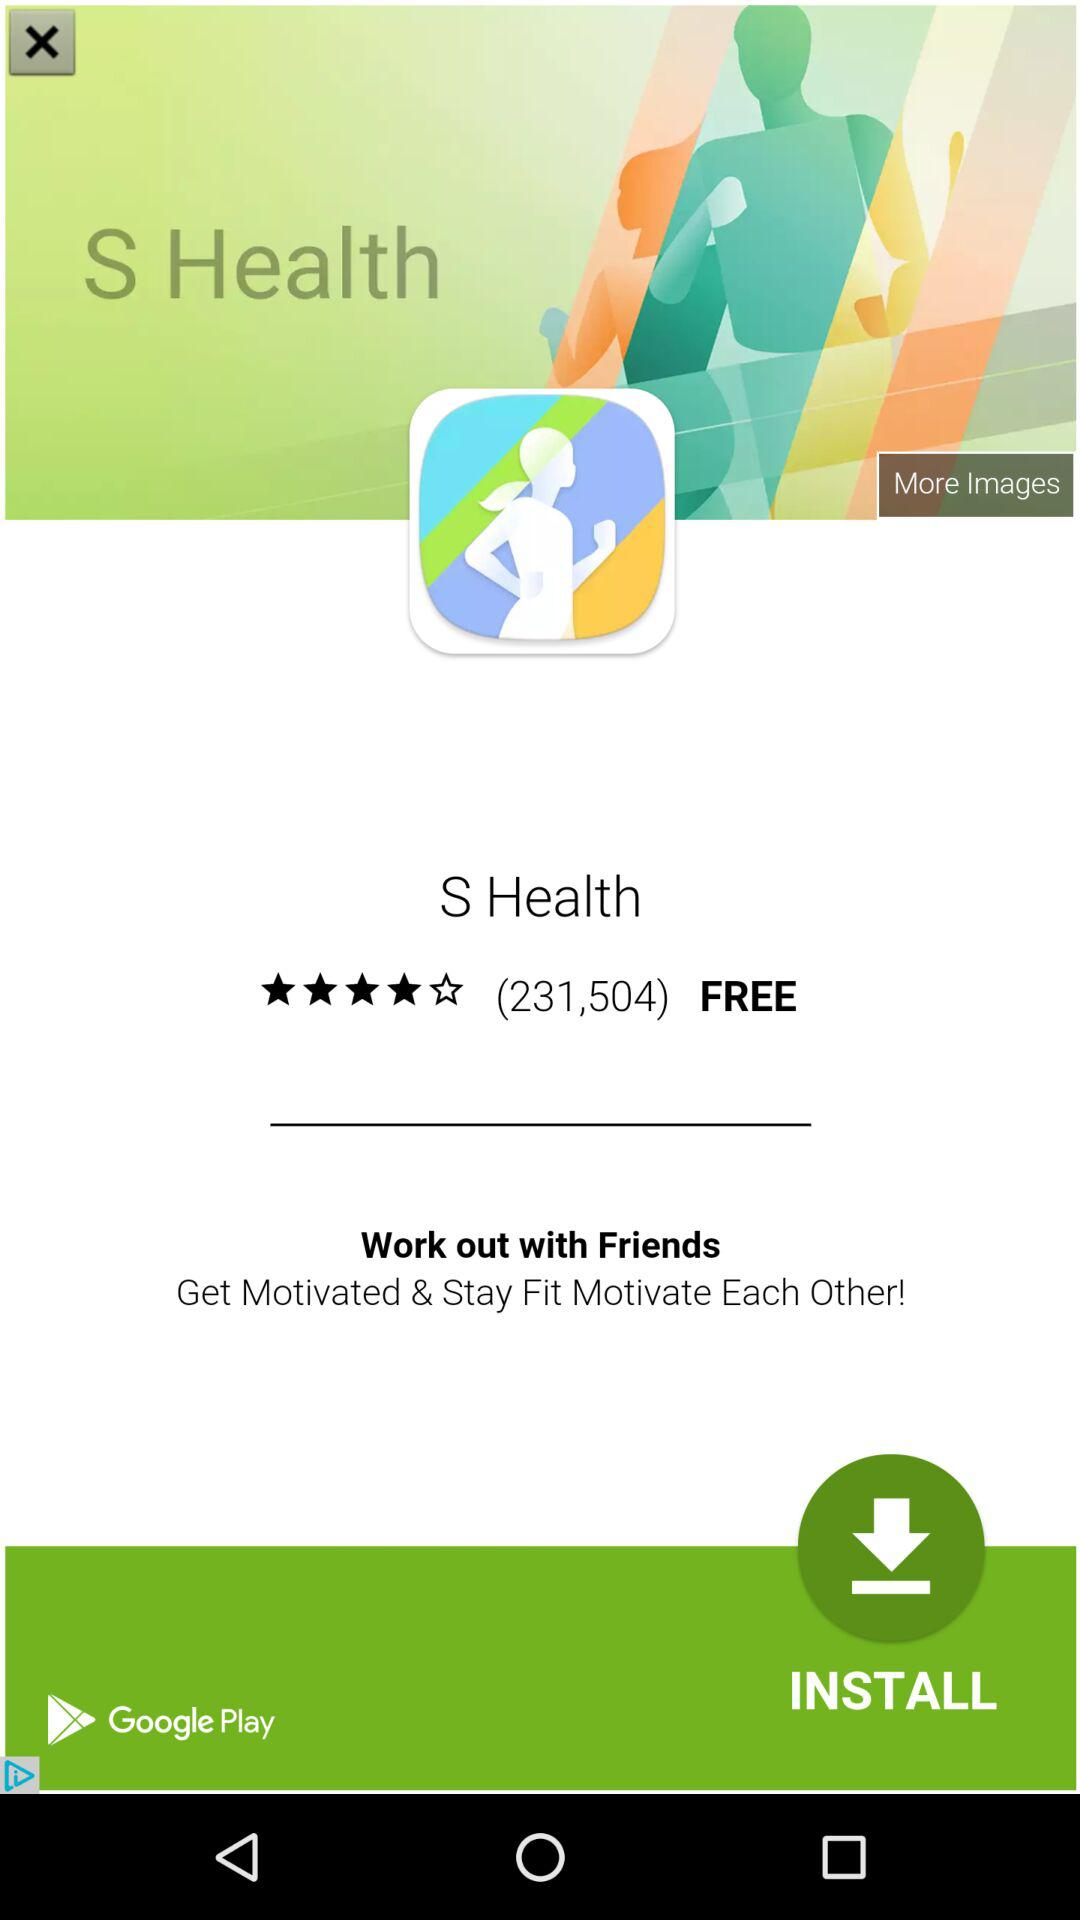How many repeats are there? There is 1 repeat. 